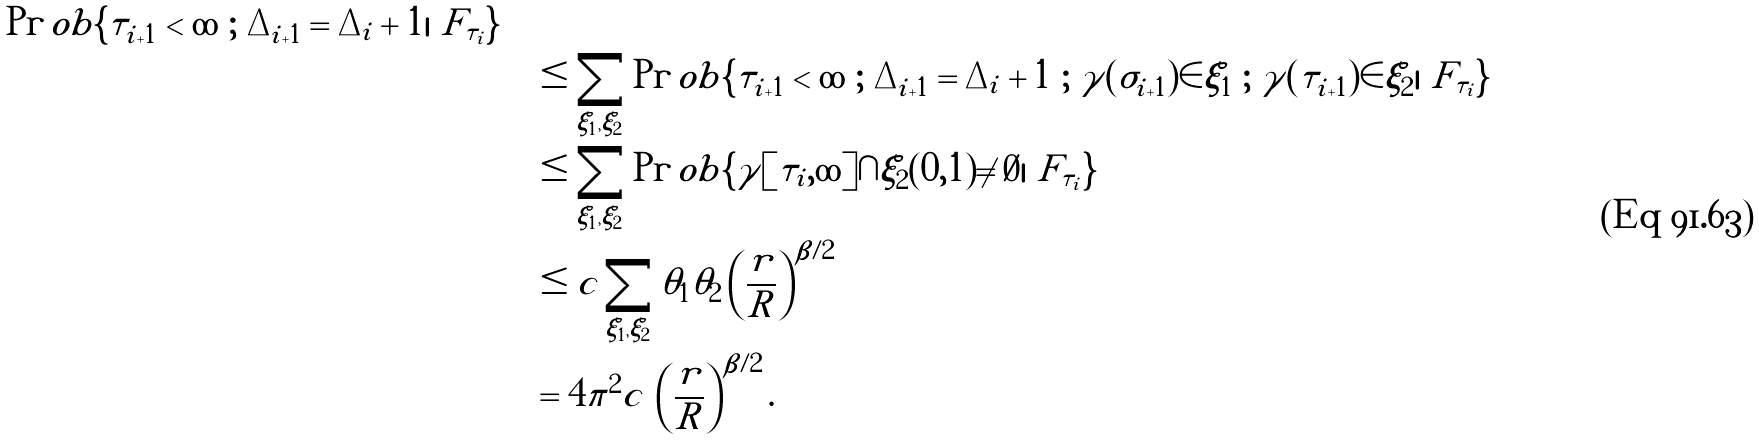Convert formula to latex. <formula><loc_0><loc_0><loc_500><loc_500>{ \Pr o b \{ \tau _ { i + 1 } < \infty \ ; \ \Delta _ { i + 1 } = \Delta _ { i } + 1 | \ F _ { \tau _ { i } } \} } \quad \\ & \leq \sum _ { \xi _ { 1 } , \xi _ { 2 } } \Pr o b \{ \tau _ { i + 1 } < \infty \ ; \ \Delta _ { i + 1 } = \Delta _ { i } + 1 \ ; \ \gamma ( \sigma _ { i + 1 } ) \in \xi _ { 1 } \ ; \ \gamma ( \tau _ { i + 1 } ) \in \xi _ { 2 } | \ F _ { \tau _ { i } } \} \\ & \leq \sum _ { \xi _ { 1 } , \xi _ { 2 } } \Pr o b \{ \gamma [ \tau _ { i } , \infty ] \cap \xi _ { 2 } ( 0 , 1 ) \neq \emptyset | \ F _ { \tau _ { i } } \} \\ & \leq c \sum _ { \xi _ { 1 } , \xi _ { 2 } } \theta _ { 1 } \theta _ { 2 } \left ( \frac { r } { R } \right ) ^ { \beta / 2 } \\ & = 4 \pi ^ { 2 } c \, \left ( \frac { r } { R } \right ) ^ { \beta / 2 } .</formula> 